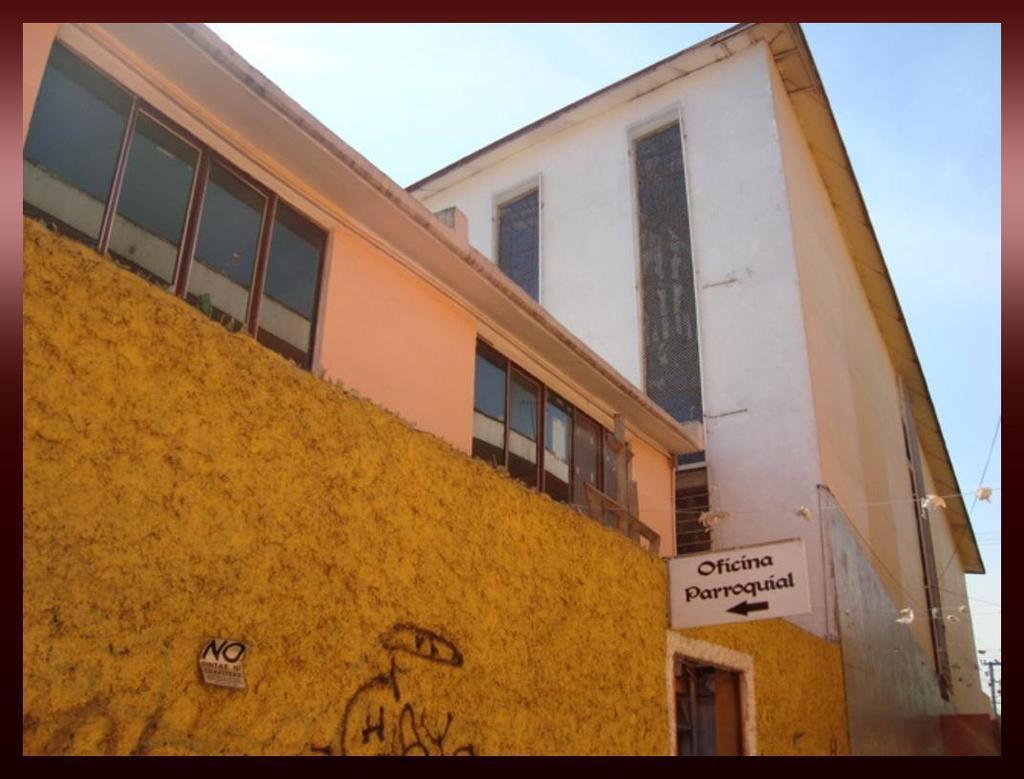Please provide a concise description of this image. In this picture I can see some buildings and sign board with some text. 